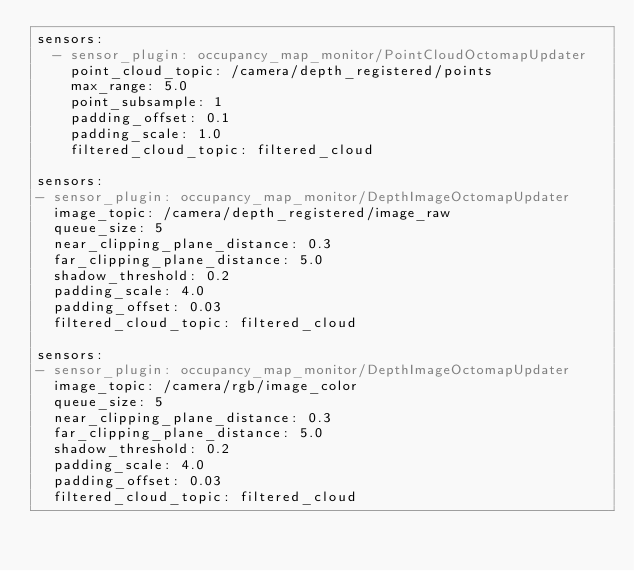<code> <loc_0><loc_0><loc_500><loc_500><_YAML_>sensors:
  - sensor_plugin: occupancy_map_monitor/PointCloudOctomapUpdater
    point_cloud_topic: /camera/depth_registered/points
    max_range: 5.0
    point_subsample: 1
    padding_offset: 0.1
    padding_scale: 1.0
    filtered_cloud_topic: filtered_cloud

sensors:
- sensor_plugin: occupancy_map_monitor/DepthImageOctomapUpdater
  image_topic: /camera/depth_registered/image_raw
  queue_size: 5
  near_clipping_plane_distance: 0.3
  far_clipping_plane_distance: 5.0
  shadow_threshold: 0.2
  padding_scale: 4.0
  padding_offset: 0.03
  filtered_cloud_topic: filtered_cloud

sensors:
- sensor_plugin: occupancy_map_monitor/DepthImageOctomapUpdater
  image_topic: /camera/rgb/image_color
  queue_size: 5
  near_clipping_plane_distance: 0.3
  far_clipping_plane_distance: 5.0
  shadow_threshold: 0.2
  padding_scale: 4.0
  padding_offset: 0.03
  filtered_cloud_topic: filtered_cloud
</code> 